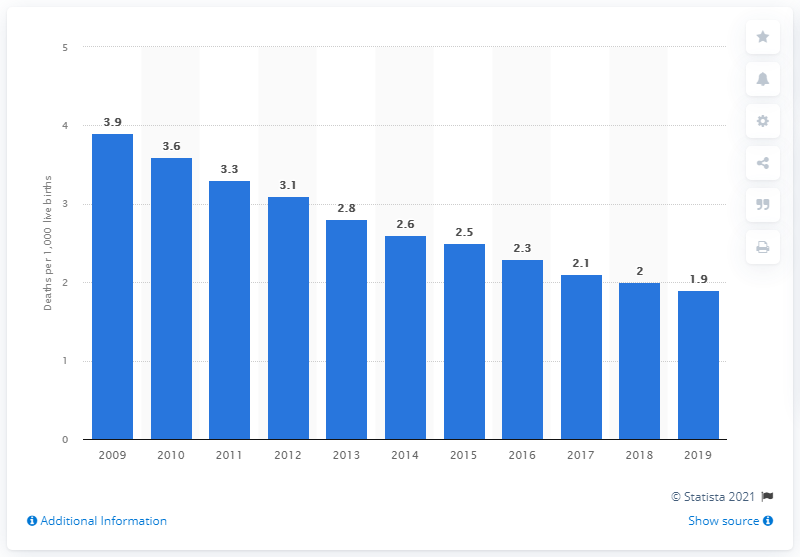List a handful of essential elements in this visual. In 2019, the infant mortality rate in Estonia was 1.9 per 1,000 live births. 